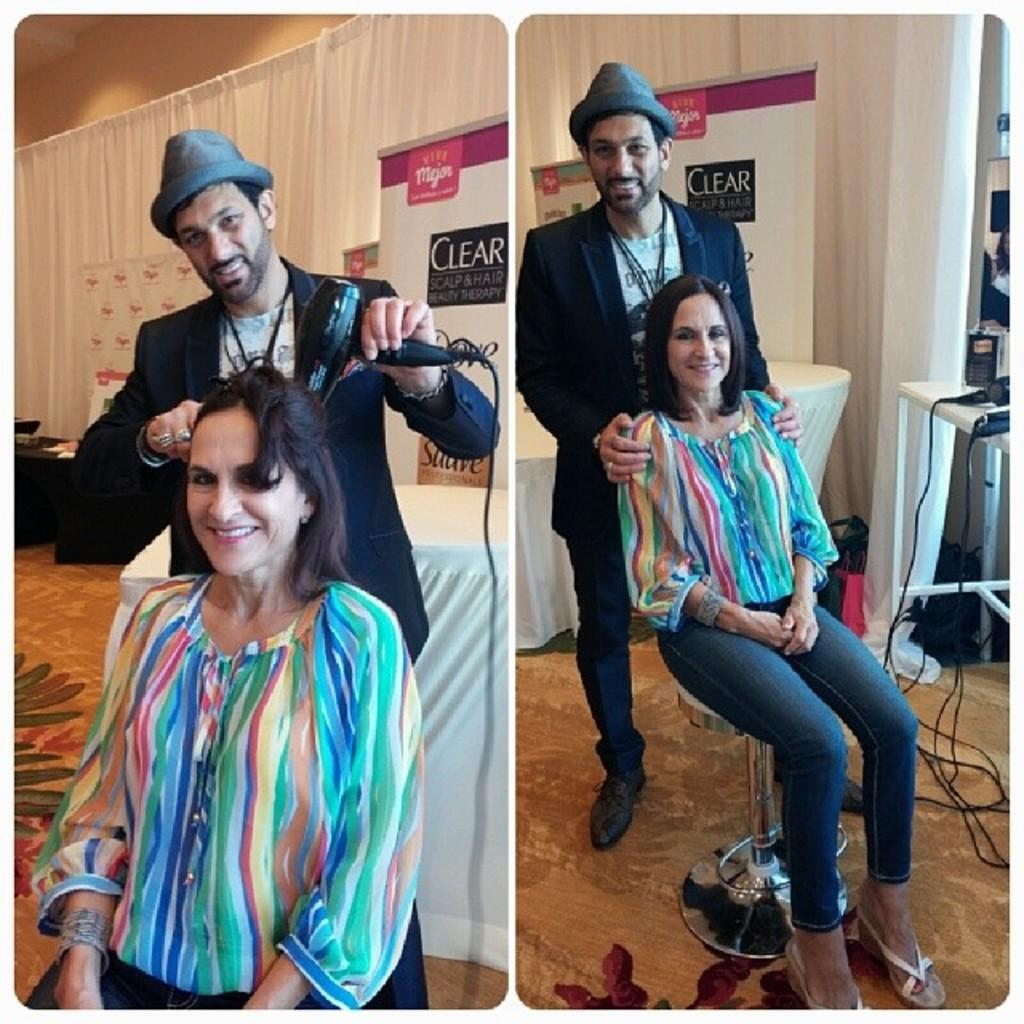How many people are the persons are in the image? There are persons in the image. What is one of the persons holding in the image? One of the persons is holding a hair dryer machine. What decorative elements can be seen in the image? There are banners and curtains in the image. What type of items are visible in the image? There are clothes and objects on a table in the image. What type of doll is sitting on the chin of one of the persons in the image? There is no doll present in the image, and no one's chin is visible. What type of lace can be seen on the curtains in the image? The provided facts do not mention any specific details about the curtains, such as the presence of lace. 